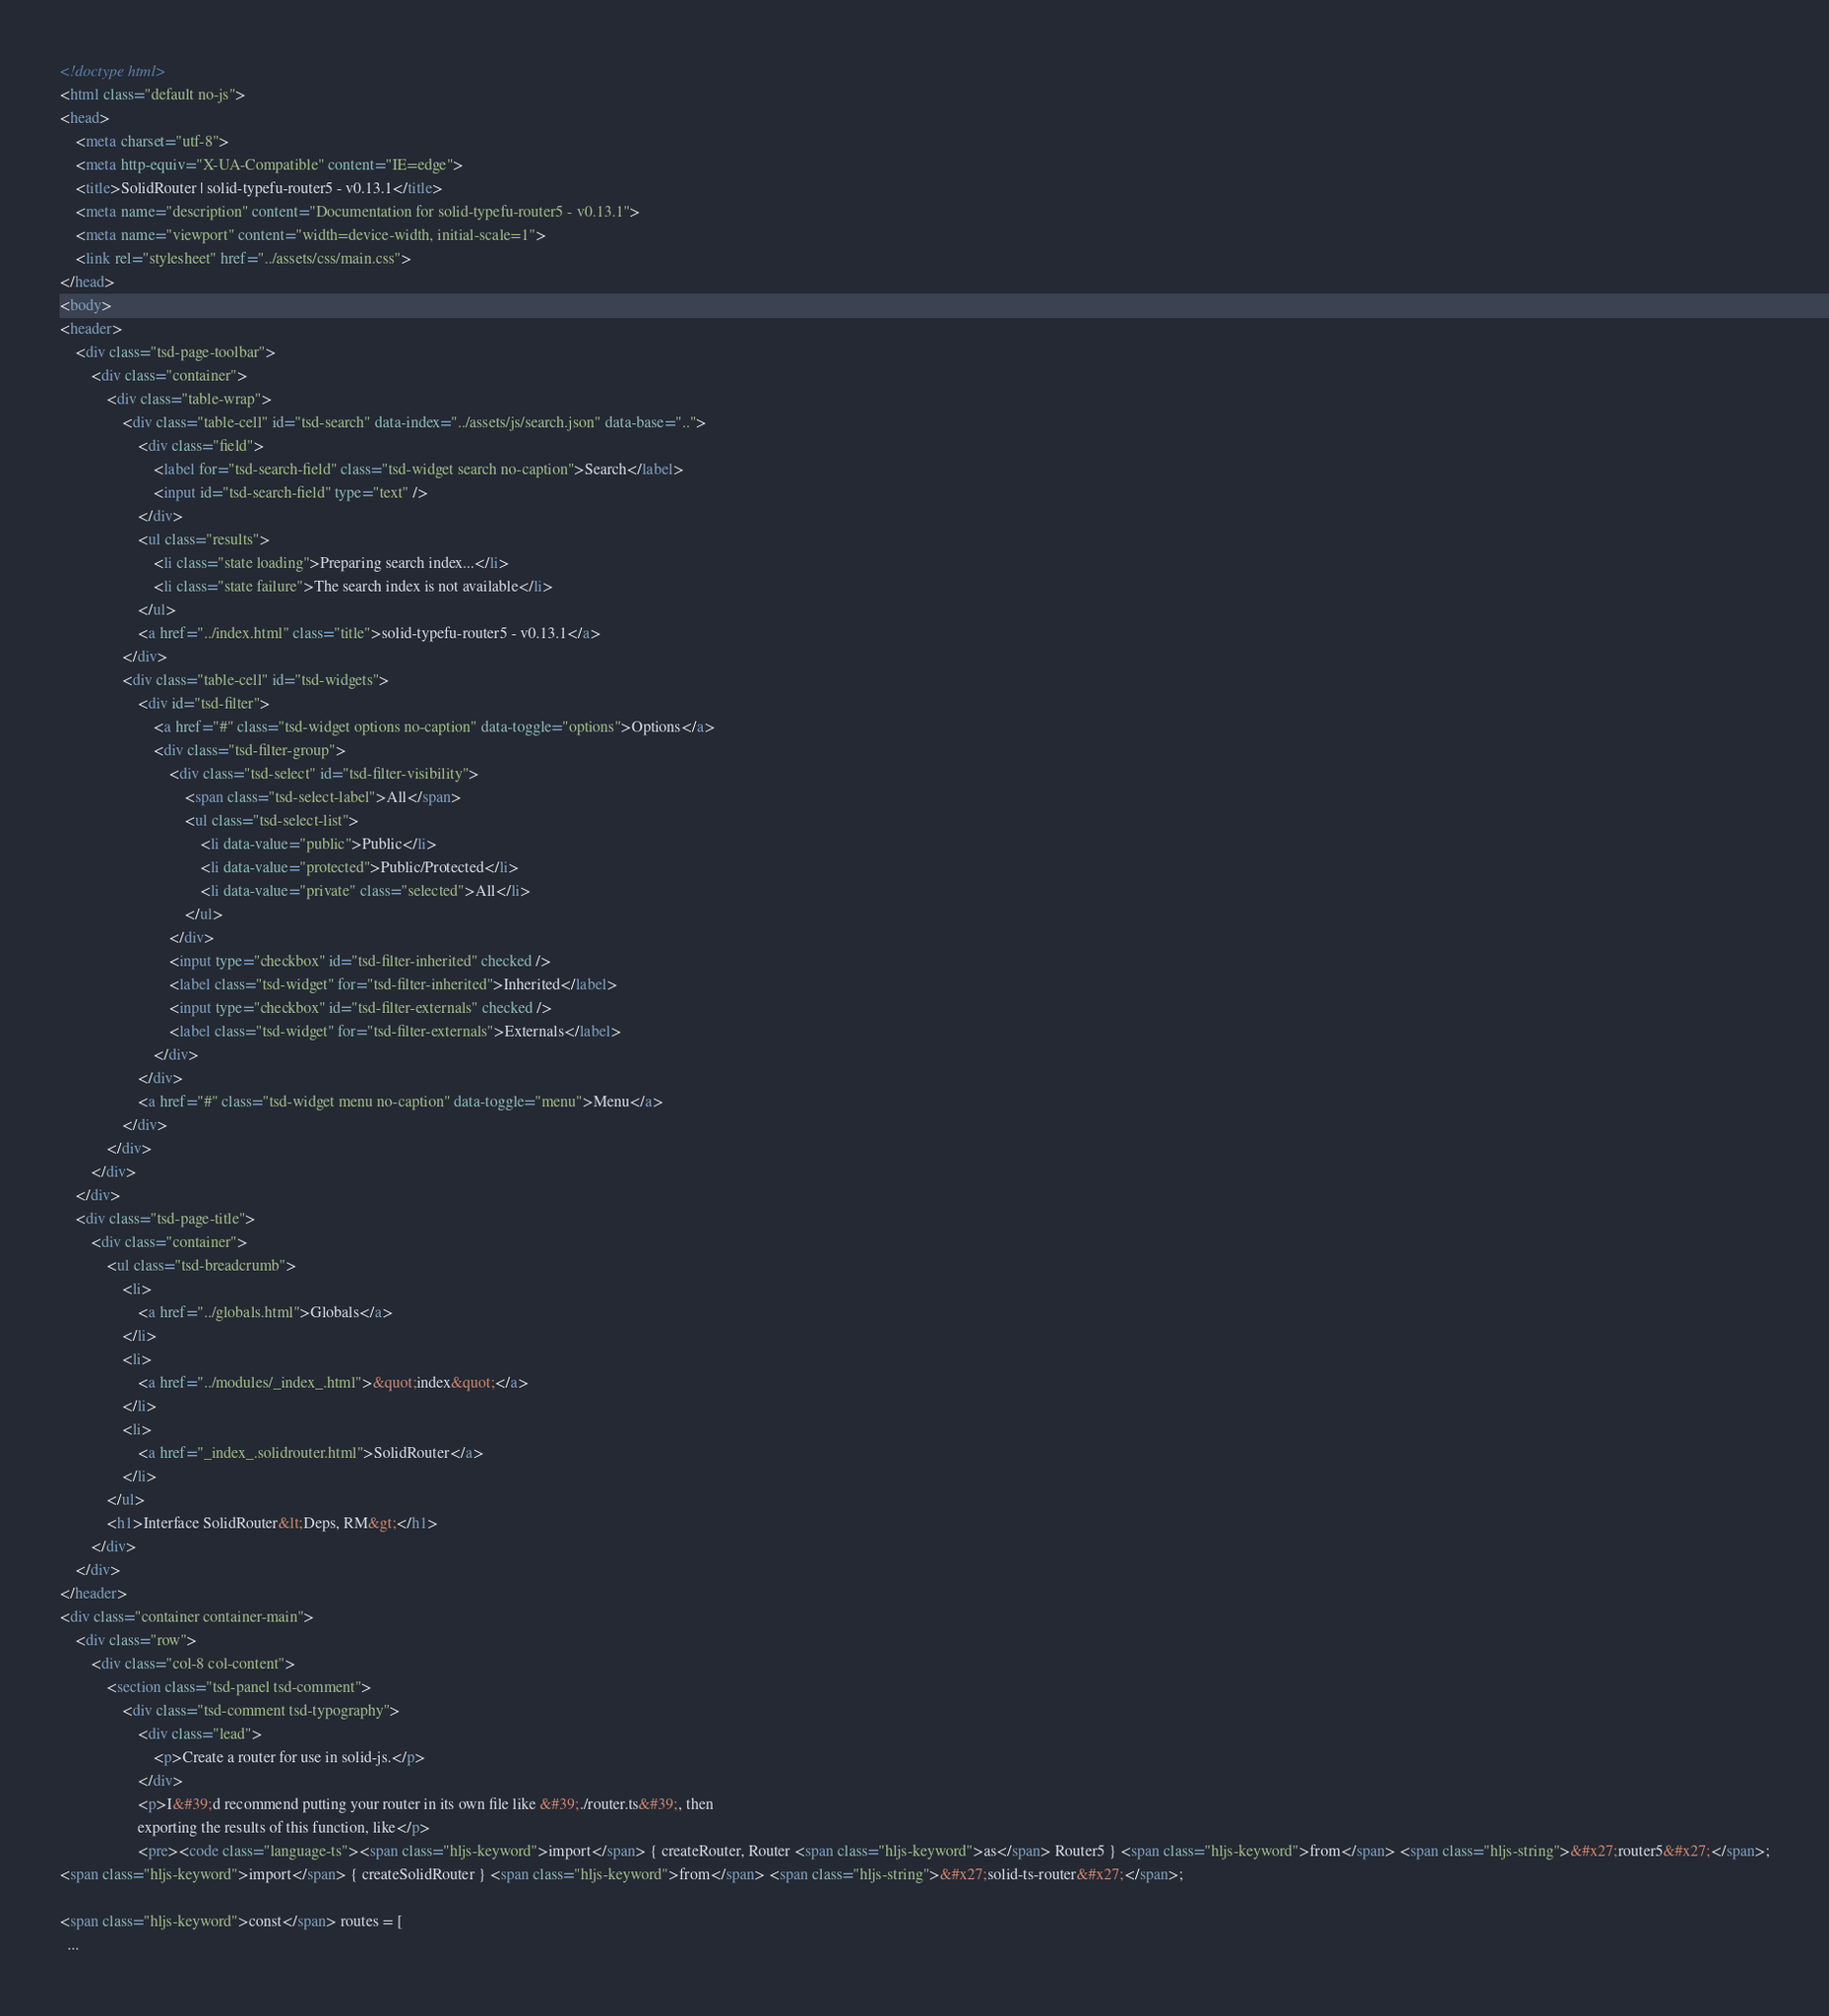<code> <loc_0><loc_0><loc_500><loc_500><_HTML_><!doctype html>
<html class="default no-js">
<head>
	<meta charset="utf-8">
	<meta http-equiv="X-UA-Compatible" content="IE=edge">
	<title>SolidRouter | solid-typefu-router5 - v0.13.1</title>
	<meta name="description" content="Documentation for solid-typefu-router5 - v0.13.1">
	<meta name="viewport" content="width=device-width, initial-scale=1">
	<link rel="stylesheet" href="../assets/css/main.css">
</head>
<body>
<header>
	<div class="tsd-page-toolbar">
		<div class="container">
			<div class="table-wrap">
				<div class="table-cell" id="tsd-search" data-index="../assets/js/search.json" data-base="..">
					<div class="field">
						<label for="tsd-search-field" class="tsd-widget search no-caption">Search</label>
						<input id="tsd-search-field" type="text" />
					</div>
					<ul class="results">
						<li class="state loading">Preparing search index...</li>
						<li class="state failure">The search index is not available</li>
					</ul>
					<a href="../index.html" class="title">solid-typefu-router5 - v0.13.1</a>
				</div>
				<div class="table-cell" id="tsd-widgets">
					<div id="tsd-filter">
						<a href="#" class="tsd-widget options no-caption" data-toggle="options">Options</a>
						<div class="tsd-filter-group">
							<div class="tsd-select" id="tsd-filter-visibility">
								<span class="tsd-select-label">All</span>
								<ul class="tsd-select-list">
									<li data-value="public">Public</li>
									<li data-value="protected">Public/Protected</li>
									<li data-value="private" class="selected">All</li>
								</ul>
							</div>
							<input type="checkbox" id="tsd-filter-inherited" checked />
							<label class="tsd-widget" for="tsd-filter-inherited">Inherited</label>
							<input type="checkbox" id="tsd-filter-externals" checked />
							<label class="tsd-widget" for="tsd-filter-externals">Externals</label>
						</div>
					</div>
					<a href="#" class="tsd-widget menu no-caption" data-toggle="menu">Menu</a>
				</div>
			</div>
		</div>
	</div>
	<div class="tsd-page-title">
		<div class="container">
			<ul class="tsd-breadcrumb">
				<li>
					<a href="../globals.html">Globals</a>
				</li>
				<li>
					<a href="../modules/_index_.html">&quot;index&quot;</a>
				</li>
				<li>
					<a href="_index_.solidrouter.html">SolidRouter</a>
				</li>
			</ul>
			<h1>Interface SolidRouter&lt;Deps, RM&gt;</h1>
		</div>
	</div>
</header>
<div class="container container-main">
	<div class="row">
		<div class="col-8 col-content">
			<section class="tsd-panel tsd-comment">
				<div class="tsd-comment tsd-typography">
					<div class="lead">
						<p>Create a router for use in solid-js.</p>
					</div>
					<p>I&#39;d recommend putting your router in its own file like &#39;./router.ts&#39;, then
					exporting the results of this function, like</p>
					<pre><code class="language-ts"><span class="hljs-keyword">import</span> { createRouter, Router <span class="hljs-keyword">as</span> Router5 } <span class="hljs-keyword">from</span> <span class="hljs-string">&#x27;router5&#x27;</span>;
<span class="hljs-keyword">import</span> { createSolidRouter } <span class="hljs-keyword">from</span> <span class="hljs-string">&#x27;solid-ts-router&#x27;</span>;

<span class="hljs-keyword">const</span> routes = [
  ...</code> 